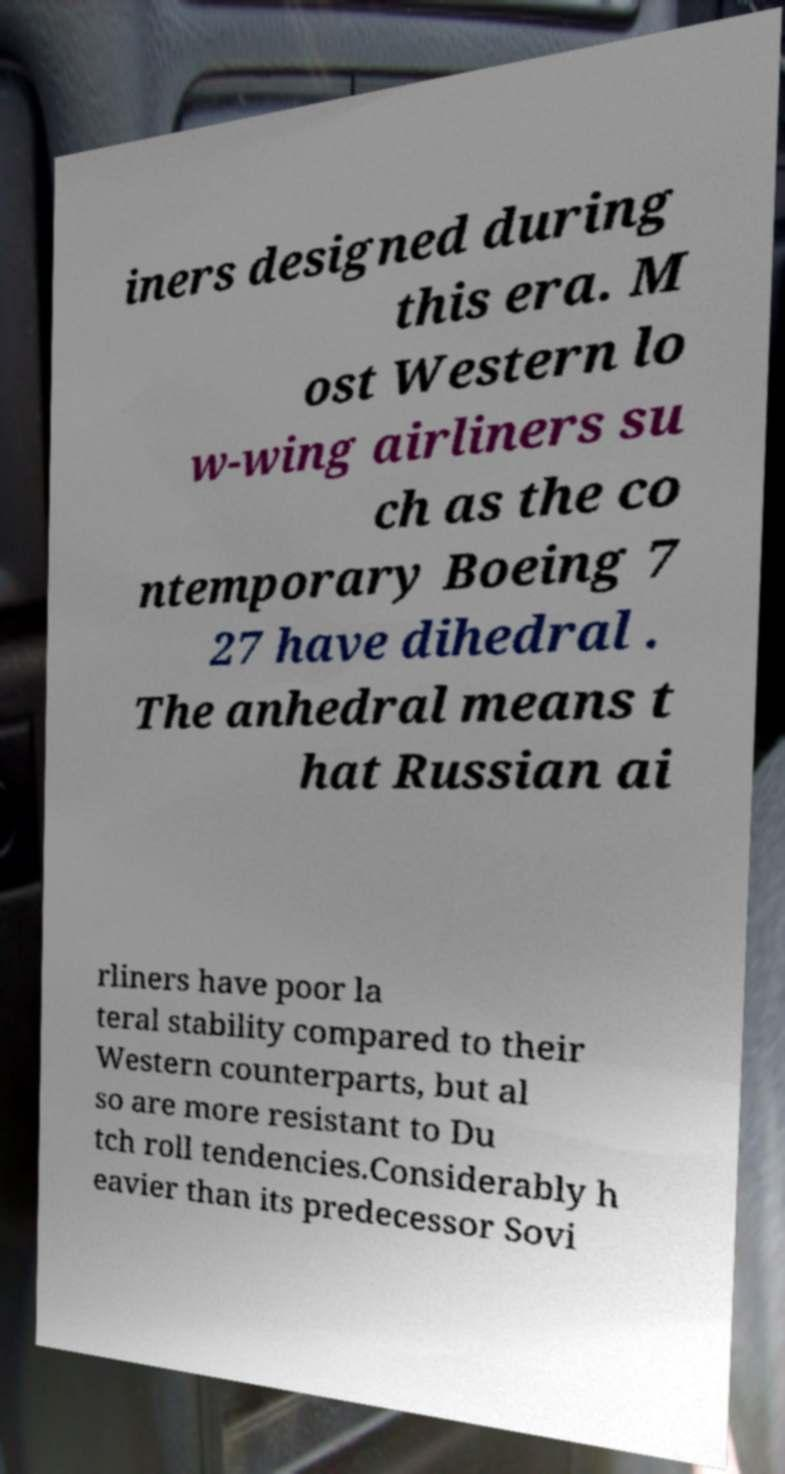Can you accurately transcribe the text from the provided image for me? iners designed during this era. M ost Western lo w-wing airliners su ch as the co ntemporary Boeing 7 27 have dihedral . The anhedral means t hat Russian ai rliners have poor la teral stability compared to their Western counterparts, but al so are more resistant to Du tch roll tendencies.Considerably h eavier than its predecessor Sovi 